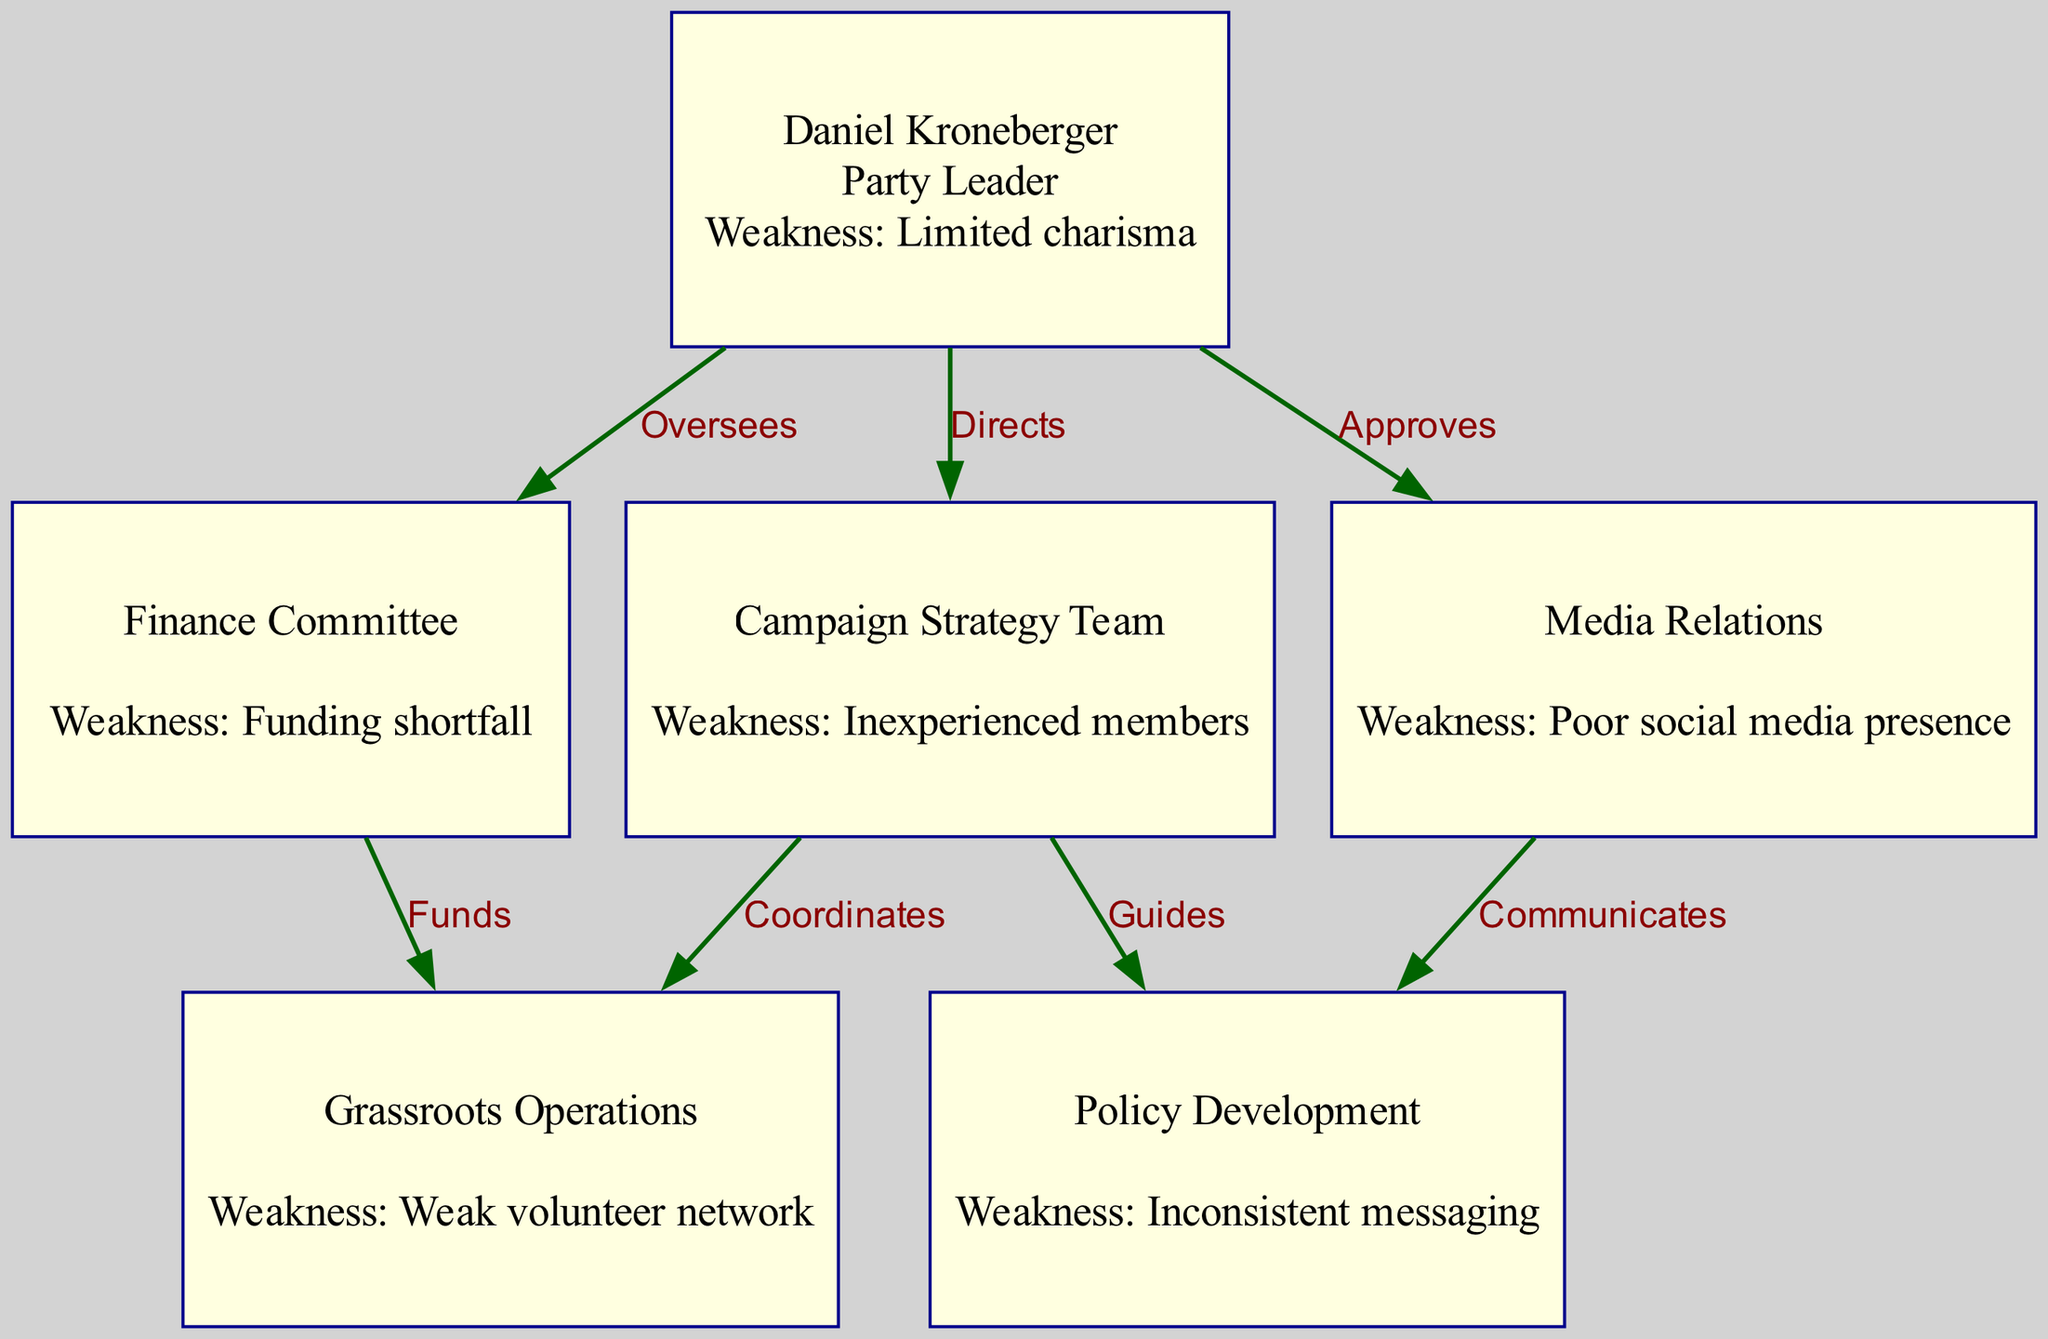What is the role of Daniel Kroneberger? The diagram indicates that Daniel Kroneberger holds the role of "Party Leader." This is directly shown in the node labeled with his name, where the role is specified.
Answer: Party Leader How many total nodes are there in the diagram? By counting the individual entries in the 'nodes' list from the data, we find that there are 6 nodes total: Kroneberger and his five committees.
Answer: 6 What is the weakness of the Finance Committee? The weakness of the Finance Committee is clearly stated in its node, which mentions "Funding shortfall." Therefore, by looking directly at that node, we can provide the answer.
Answer: Funding shortfall Who does the Campaign Strategy Team coordinate with? According to the diagram, the Campaign Strategy Team coordinates with the Grassroots Operations node. This is indicated by the edge labeled "Coordinates" connecting the two.
Answer: Grassroots Operations How many edges connect Daniel Kroneberger to other nodes? The diagram shows that Daniel Kroneberger has three edges connecting him to other nodes. Each of these connections represents his direct relationships (Directs, Oversees, Approves) with the Campaign Strategy Team, Finance Committee, and Media Relations respectively.
Answer: 3 What type of messaging issue is highlighted under Policy Development? The diagram highlights "Inconsistent messaging" as the noted weakness of the Policy Development node. This is specifically mentioned in the description of that node.
Answer: Inconsistent messaging Which committee has a weakness related to social media? The weakness related to social media is associated with the Media Relations node, which indicates a "Poor social media presence." This information is provided directly in the description for that committee.
Answer: Poor social media presence Which committee does Daniel Kroneberger oversee? The diagram shows that Daniel Kroneberger oversees the Finance Committee, as indicated by the connection labeled "Oversees." This relationship is explicit in the structure of the diagram.
Answer: Finance Committee What relationship does Media Relations have with Policy Development? The relationship between Media Relations and Policy Development is defined by the edge labeled "Communicates." This indicates that Media Relations plays a communicative role regarding policy development in the organization.
Answer: Communicates 